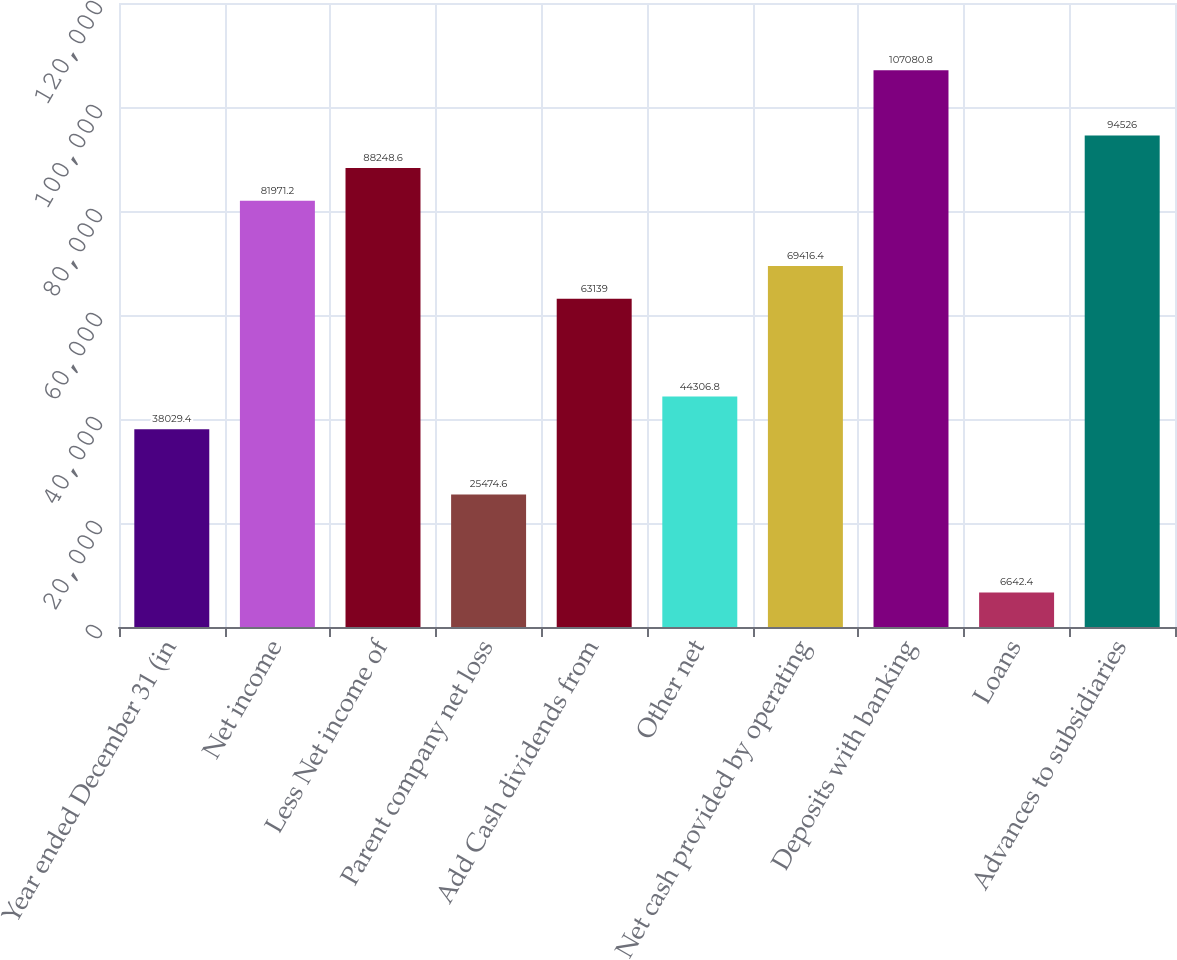Convert chart. <chart><loc_0><loc_0><loc_500><loc_500><bar_chart><fcel>Year ended December 31 (in<fcel>Net income<fcel>Less Net income of<fcel>Parent company net loss<fcel>Add Cash dividends from<fcel>Other net<fcel>Net cash provided by operating<fcel>Deposits with banking<fcel>Loans<fcel>Advances to subsidiaries<nl><fcel>38029.4<fcel>81971.2<fcel>88248.6<fcel>25474.6<fcel>63139<fcel>44306.8<fcel>69416.4<fcel>107081<fcel>6642.4<fcel>94526<nl></chart> 